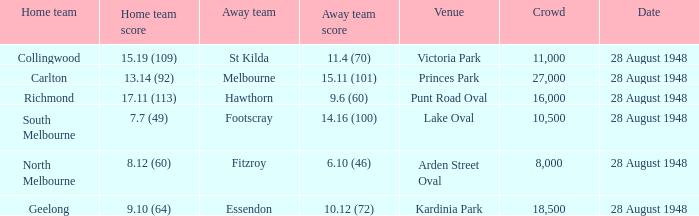What is the St Kilda Away team score? 11.4 (70). 